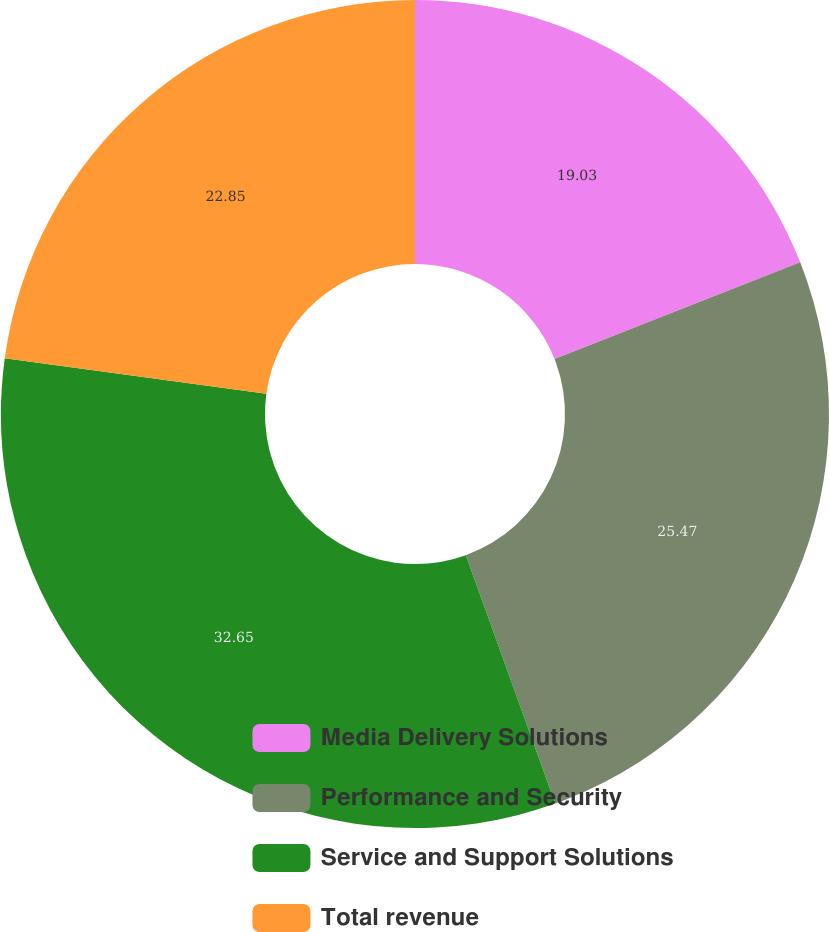<chart> <loc_0><loc_0><loc_500><loc_500><pie_chart><fcel>Media Delivery Solutions<fcel>Performance and Security<fcel>Service and Support Solutions<fcel>Total revenue<nl><fcel>19.03%<fcel>25.47%<fcel>32.65%<fcel>22.85%<nl></chart> 